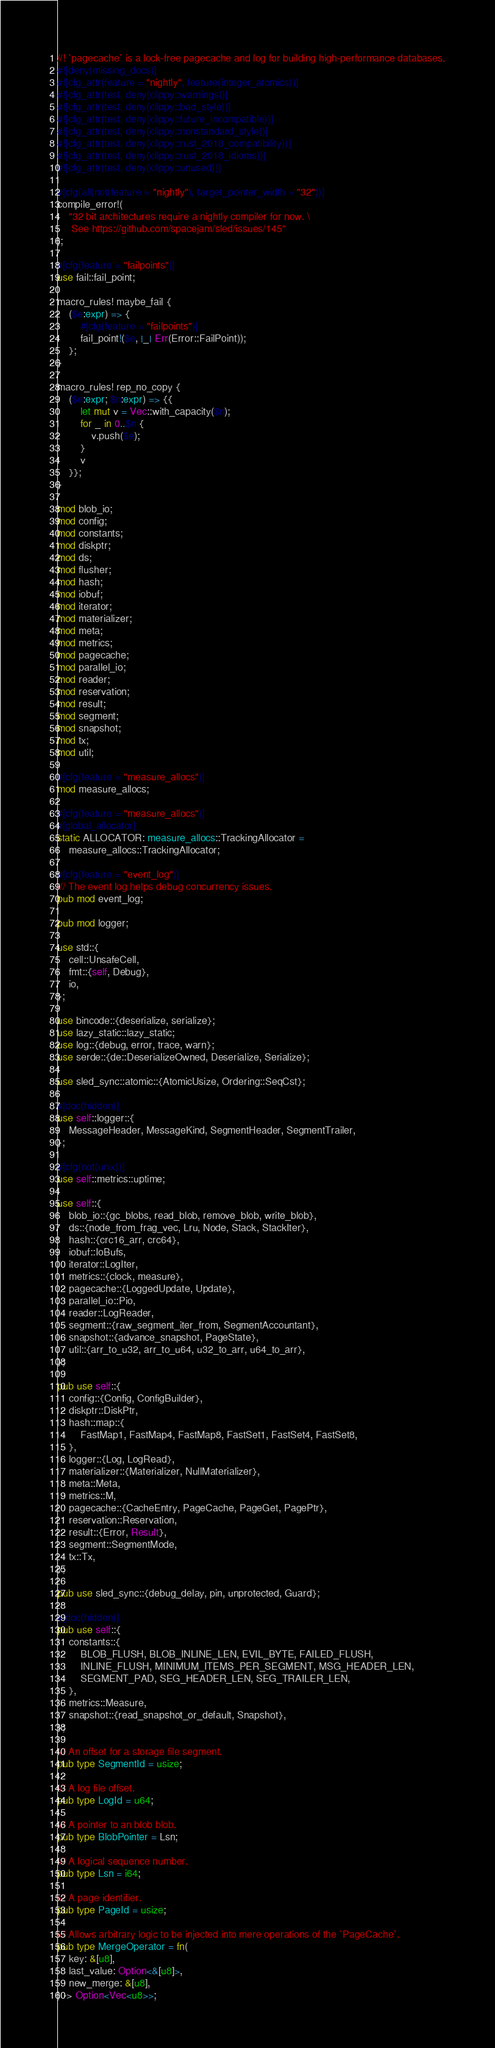<code> <loc_0><loc_0><loc_500><loc_500><_Rust_>//! `pagecache` is a lock-free pagecache and log for building high-performance databases.
#![deny(missing_docs)]
#![cfg_attr(feature = "nightly", feature(integer_atomics))]
#![cfg_attr(test, deny(clippy::warnings))]
#![cfg_attr(test, deny(clippy::bad_style))]
#![cfg_attr(test, deny(clippy::future_incompatible))]
#![cfg_attr(test, deny(clippy::nonstandard_style))]
#![cfg_attr(test, deny(clippy::rust_2018_compatibility))]
#![cfg_attr(test, deny(clippy::rust_2018_idioms))]
#![cfg_attr(test, deny(clippy::unused))]

#[cfg(all(not(feature = "nightly"), target_pointer_width = "32"))]
compile_error!(
    "32 bit architectures require a nightly compiler for now. \
     See https://github.com/spacejam/sled/issues/145"
);

#[cfg(feature = "failpoints")]
use fail::fail_point;

macro_rules! maybe_fail {
    ($e:expr) => {
        #[cfg(feature = "failpoints")]
        fail_point!($e, |_| Err(Error::FailPoint));
    };
}

macro_rules! rep_no_copy {
    ($e:expr; $n:expr) => {{
        let mut v = Vec::with_capacity($n);
        for _ in 0..$n {
            v.push($e);
        }
        v
    }};
}

mod blob_io;
mod config;
mod constants;
mod diskptr;
mod ds;
mod flusher;
mod hash;
mod iobuf;
mod iterator;
mod materializer;
mod meta;
mod metrics;
mod pagecache;
mod parallel_io;
mod reader;
mod reservation;
mod result;
mod segment;
mod snapshot;
mod tx;
mod util;

#[cfg(feature = "measure_allocs")]
mod measure_allocs;

#[cfg(feature = "measure_allocs")]
#[global_allocator]
static ALLOCATOR: measure_allocs::TrackingAllocator =
    measure_allocs::TrackingAllocator;

#[cfg(feature = "event_log")]
/// The event log helps debug concurrency issues.
pub mod event_log;

pub mod logger;

use std::{
    cell::UnsafeCell,
    fmt::{self, Debug},
    io,
};

use bincode::{deserialize, serialize};
use lazy_static::lazy_static;
use log::{debug, error, trace, warn};
use serde::{de::DeserializeOwned, Deserialize, Serialize};

use sled_sync::atomic::{AtomicUsize, Ordering::SeqCst};

#[doc(hidden)]
use self::logger::{
    MessageHeader, MessageKind, SegmentHeader, SegmentTrailer,
};

#[cfg(not(unix))]
use self::metrics::uptime;

use self::{
    blob_io::{gc_blobs, read_blob, remove_blob, write_blob},
    ds::{node_from_frag_vec, Lru, Node, Stack, StackIter},
    hash::{crc16_arr, crc64},
    iobuf::IoBufs,
    iterator::LogIter,
    metrics::{clock, measure},
    pagecache::{LoggedUpdate, Update},
    parallel_io::Pio,
    reader::LogReader,
    segment::{raw_segment_iter_from, SegmentAccountant},
    snapshot::{advance_snapshot, PageState},
    util::{arr_to_u32, arr_to_u64, u32_to_arr, u64_to_arr},
};

pub use self::{
    config::{Config, ConfigBuilder},
    diskptr::DiskPtr,
    hash::map::{
        FastMap1, FastMap4, FastMap8, FastSet1, FastSet4, FastSet8,
    },
    logger::{Log, LogRead},
    materializer::{Materializer, NullMaterializer},
    meta::Meta,
    metrics::M,
    pagecache::{CacheEntry, PageCache, PageGet, PagePtr},
    reservation::Reservation,
    result::{Error, Result},
    segment::SegmentMode,
    tx::Tx,
};

pub use sled_sync::{debug_delay, pin, unprotected, Guard};

#[doc(hidden)]
pub use self::{
    constants::{
        BLOB_FLUSH, BLOB_INLINE_LEN, EVIL_BYTE, FAILED_FLUSH,
        INLINE_FLUSH, MINIMUM_ITEMS_PER_SEGMENT, MSG_HEADER_LEN,
        SEGMENT_PAD, SEG_HEADER_LEN, SEG_TRAILER_LEN,
    },
    metrics::Measure,
    snapshot::{read_snapshot_or_default, Snapshot},
};

/// An offset for a storage file segment.
pub type SegmentId = usize;

/// A log file offset.
pub type LogId = u64;

/// A pointer to an blob blob.
pub type BlobPointer = Lsn;

/// A logical sequence number.
pub type Lsn = i64;

/// A page identifier.
pub type PageId = usize;

/// Allows arbitrary logic to be injected into mere operations of the `PageCache`.
pub type MergeOperator = fn(
    key: &[u8],
    last_value: Option<&[u8]>,
    new_merge: &[u8],
) -> Option<Vec<u8>>;
</code> 